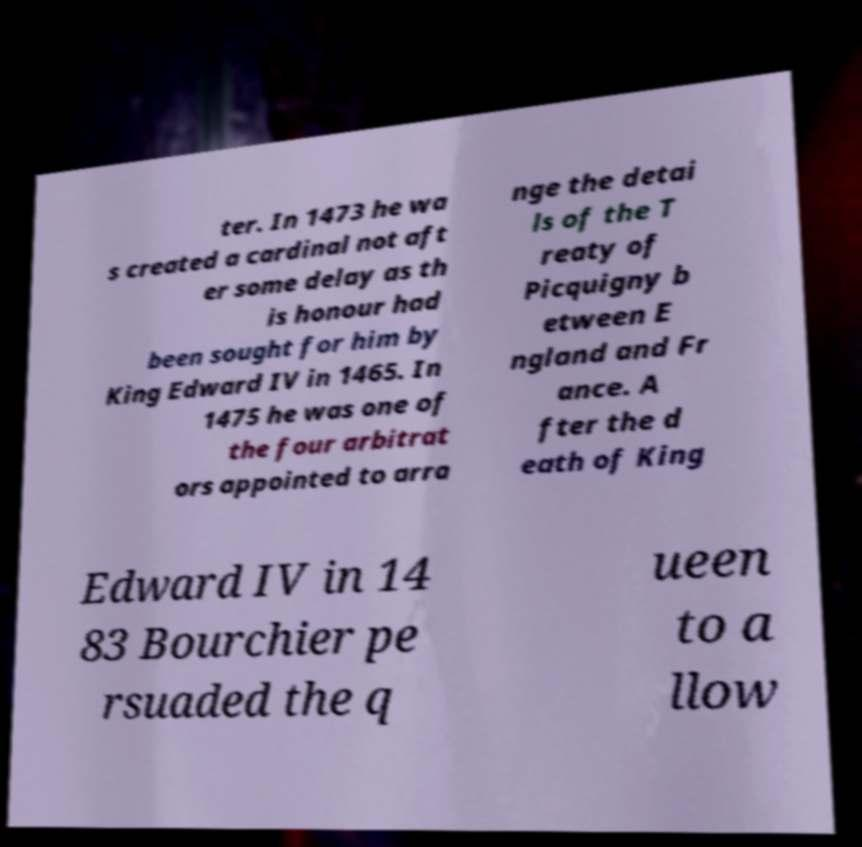I need the written content from this picture converted into text. Can you do that? ter. In 1473 he wa s created a cardinal not aft er some delay as th is honour had been sought for him by King Edward IV in 1465. In 1475 he was one of the four arbitrat ors appointed to arra nge the detai ls of the T reaty of Picquigny b etween E ngland and Fr ance. A fter the d eath of King Edward IV in 14 83 Bourchier pe rsuaded the q ueen to a llow 